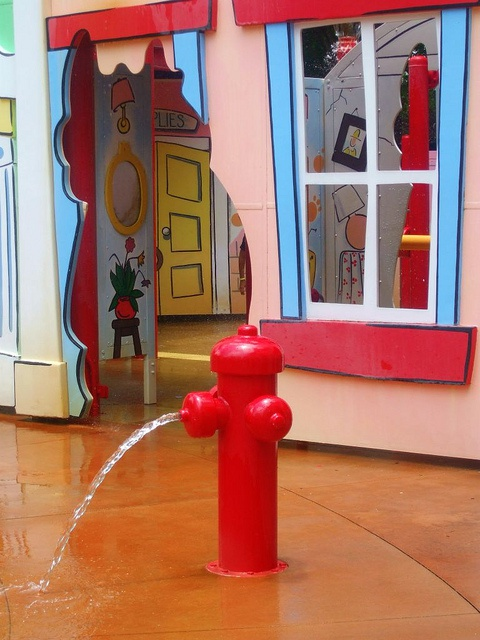Describe the objects in this image and their specific colors. I can see fire hydrant in aquamarine, brown, salmon, and red tones and potted plant in aquamarine, black, maroon, and gray tones in this image. 